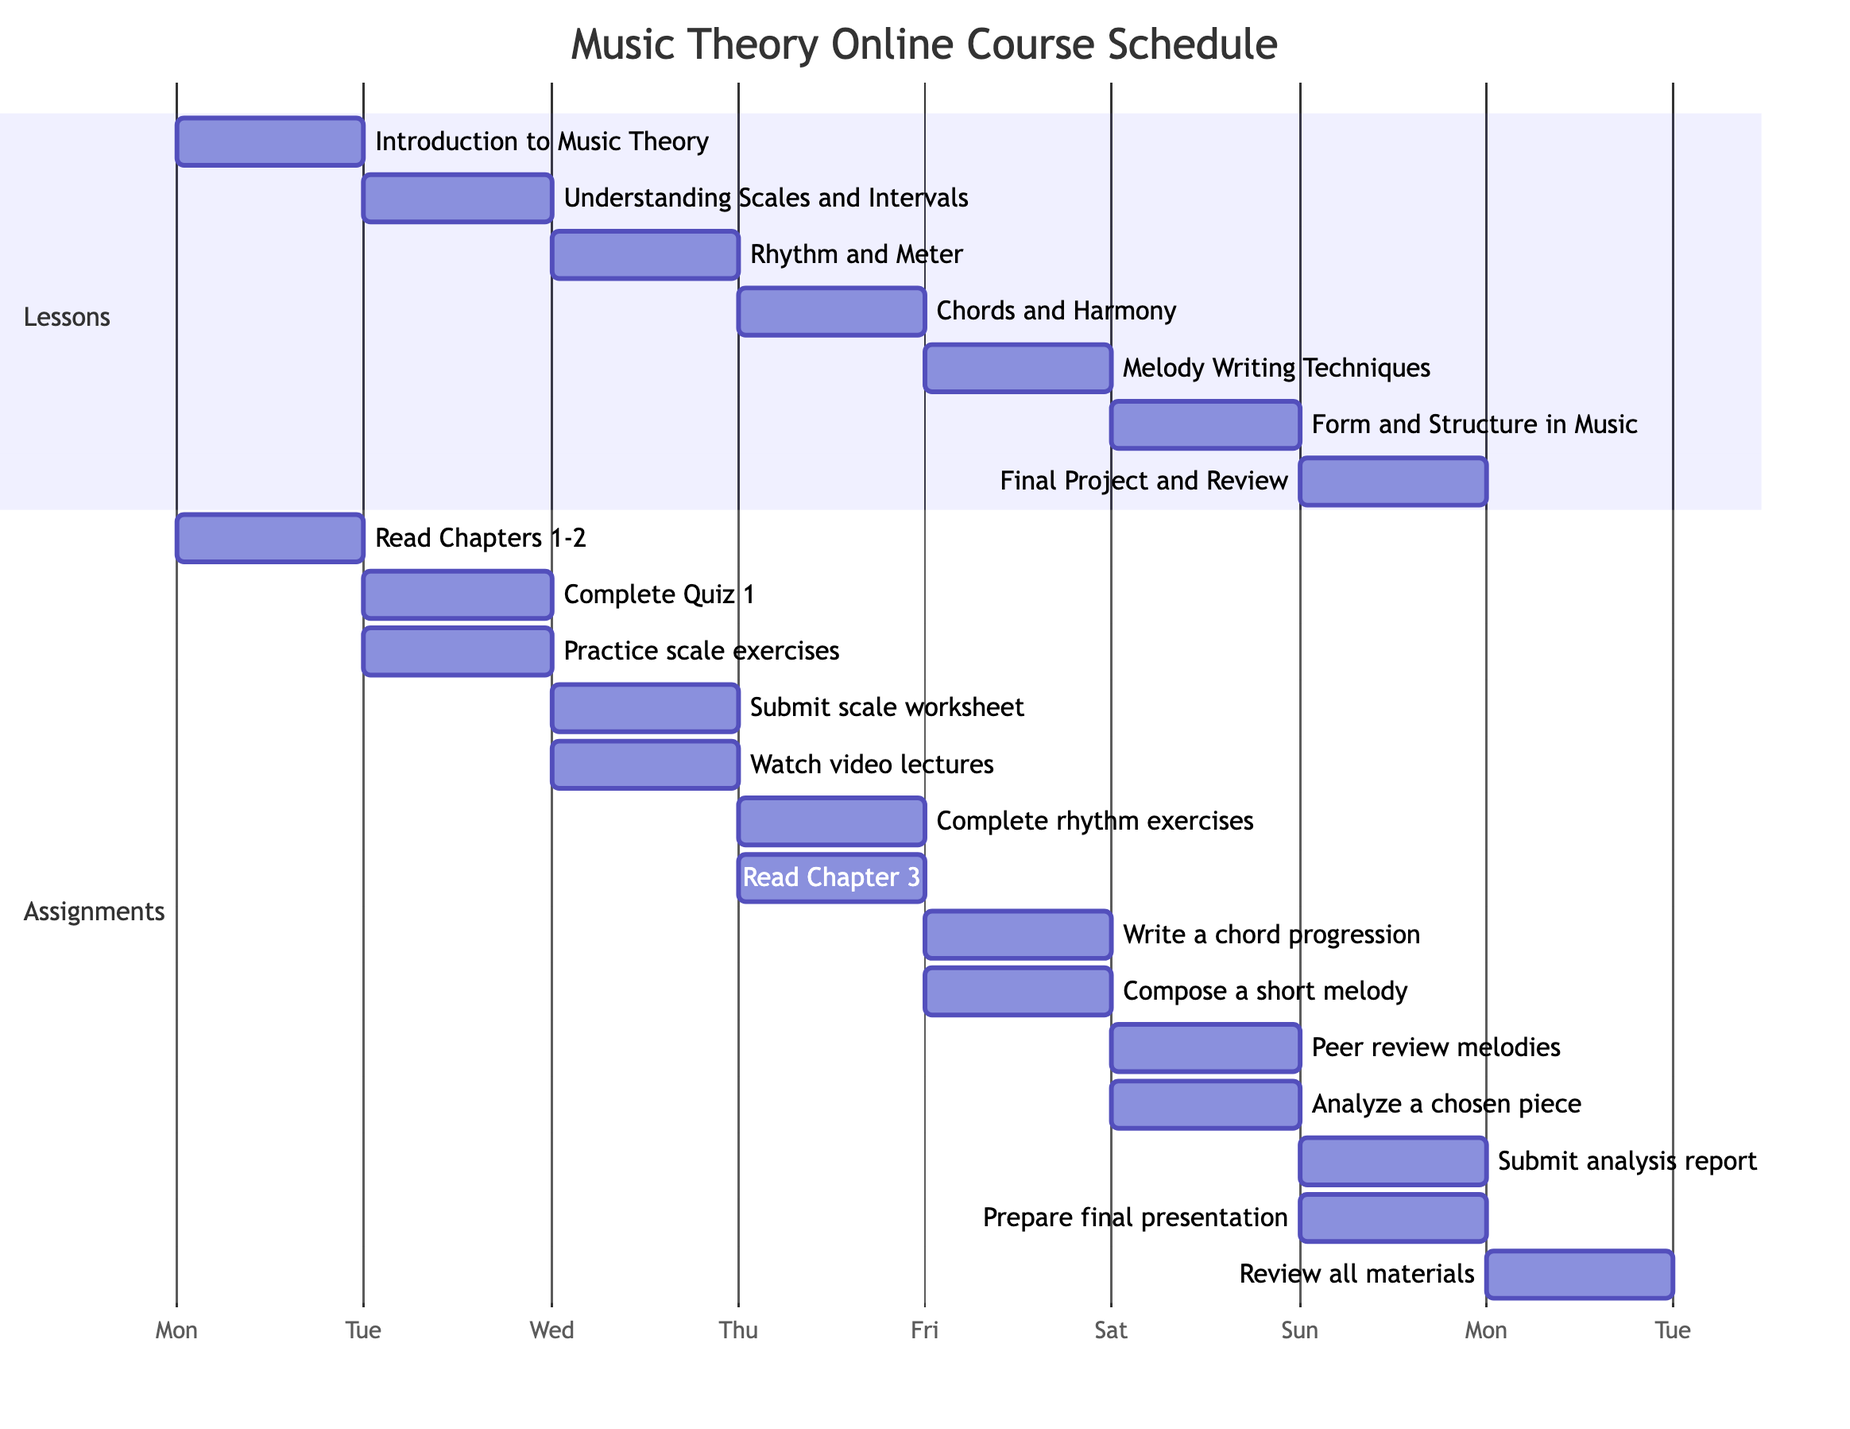What lesson is scheduled for Wednesday? The Gantt Chart indicates the lesson scheduled for Wednesday is listed under that day's section. Referring to the diagram, Wednesday corresponds to the lesson labeled "Rhythm and Meter."
Answer: Rhythm and Meter How many assignments are due on Friday? The Friday section of the Gantt Chart outlines two assignments: "Compose a short melody" and "Peer review melodies." Thus, counting these assignments gives us the total of two for that day.
Answer: 2 What is the time duration of each lesson? In the Gantt Chart, each lesson is represented as a single block on the diagram lasting for one day, which is consistent across all lessons.
Answer: 1 day On which day is the final project presentation due? By examining the final section of the Gantt Chart, we note that the "Prepare final presentation" assignment is scheduled for Sunday.
Answer: Sunday What assignment follows after completing the quiz on Monday? The diagram indicates the assignment sequence from Monday's tasks. After completing "Complete Quiz 1," the next assignment is "Practice scale exercises" on Tuesday.
Answer: Practice scale exercises Which lesson involves analyzing a chosen piece? The Gantt Chart shows that "Analyze a chosen piece" is part of the assignments for Saturday, which focuses on the lesson "Form and Structure in Music."
Answer: Form and Structure in Music What comes immediately after the "Write a chord progression" assignment? In the diagram's sequence under Thursday's assignments, "Write a chord progression" is followed directly by "Compose a short melody" on Friday.
Answer: Compose a short melody How many total lessons are included in this week-long course? The Gantt Chart displays a section for lessons, detailing each lesson for every day from Monday to Sunday. Counting the entries indicates a total of seven distinct lessons.
Answer: 7 Which day has the lesson with the highest assignment count? To determine which day has the highest assignment count, we evaluate the assignments listed under each lesson's section. On Friday, there are two assignments, while other days typically have one each. Thus, Friday qualifies as having the highest number of assignments.
Answer: Friday 